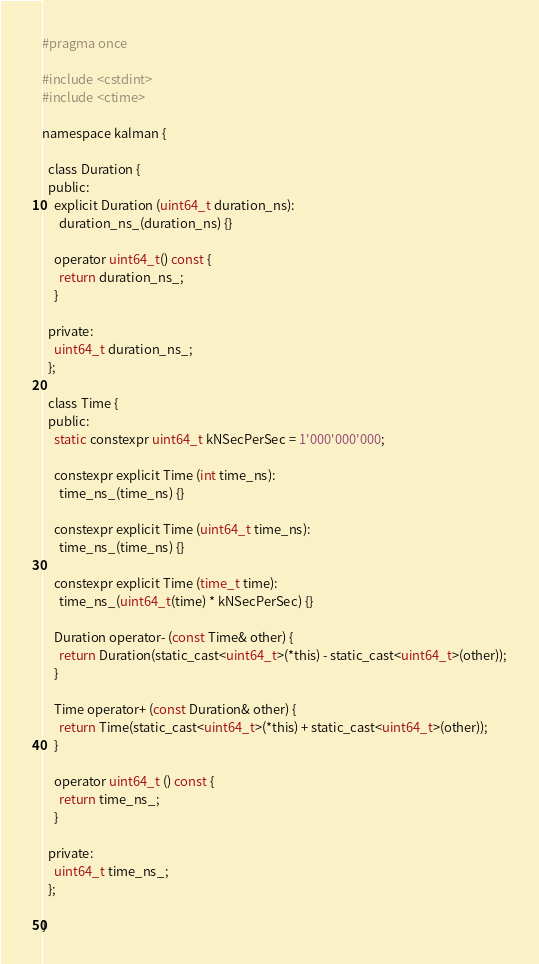Convert code to text. <code><loc_0><loc_0><loc_500><loc_500><_C_>#pragma once

#include <cstdint>
#include <ctime>

namespace kalman {

  class Duration {
  public:
    explicit Duration (uint64_t duration_ns):
      duration_ns_(duration_ns) {}
    
    operator uint64_t() const {
      return duration_ns_;
    }
    
  private:
    uint64_t duration_ns_;
  };

  class Time {
  public:
    static constexpr uint64_t kNSecPerSec = 1'000'000'000;

    constexpr explicit Time (int time_ns):
      time_ns_(time_ns) {}
    
    constexpr explicit Time (uint64_t time_ns):
      time_ns_(time_ns) {}

    constexpr explicit Time (time_t time):
      time_ns_(uint64_t(time) * kNSecPerSec) {}

    Duration operator- (const Time& other) {
      return Duration(static_cast<uint64_t>(*this) - static_cast<uint64_t>(other));
    }

    Time operator+ (const Duration& other) {
      return Time(static_cast<uint64_t>(*this) + static_cast<uint64_t>(other));
    }
    
    operator uint64_t () const {
      return time_ns_;
    }
    
  private:
    uint64_t time_ns_;
  };
  
}
</code> 